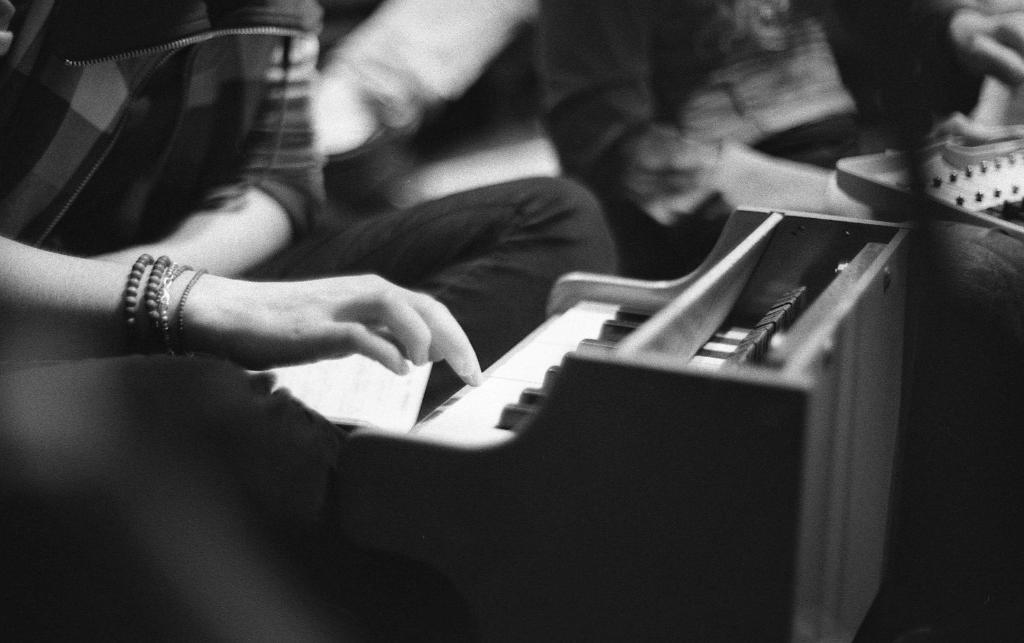Who or what is on the left side of the image? There is a person on the left side of the image. What is the person doing in the image? The person is playing the piano. Can you describe the person's face in the image? The person's face is not visible in the image. What type of knowledge does the person have about folding clothes in the image? There is no information about folding clothes or any related knowledge in the image. 